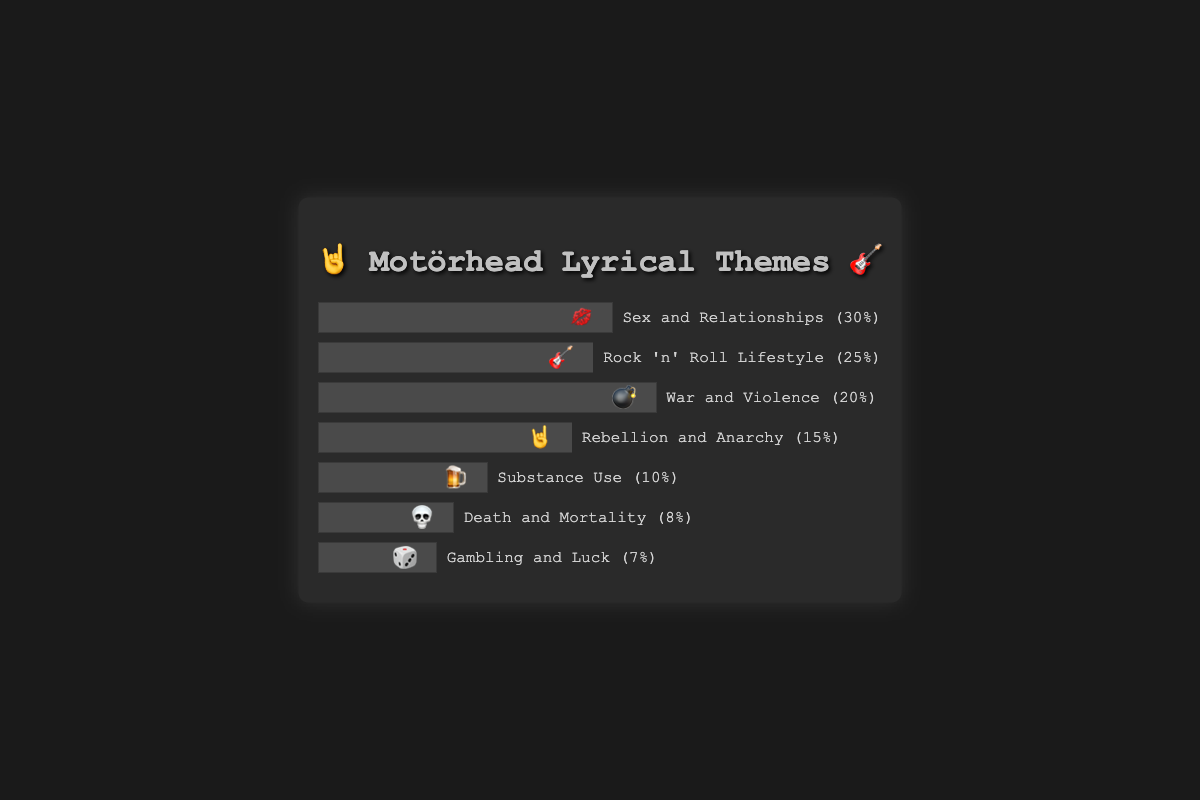What theme appears most frequently in Motörhead's songs? The theme with the highest frequency bar indicates it occurs most often. "Sex and Relationships" has the longest bar.
Answer: Sex and Relationships 💋 How many themes cover 15% or more of the songs? Identify the themes whose frequency percentages are 15 or above by looking at the length of the bars and their labels. The themes are "Sex and Relationships" (30%), "Rock 'n' Roll Lifestyle" (25%), "War and Violence" (20%), and "Rebellion and Anarchy" (15%).
Answer: Four themes Which is the least frequent theme? The theme with the shortest bar indicates it occurs the least. "Gambling and Luck" has the shortest bar.
Answer: Gambling and Luck 🎲 What is the combined frequency percentage of the "War and Violence" and "Substance Use" themes? Add the frequencies of "War and Violence" (20%) and "Substance Use" (10%). The combined frequency is 20% + 10% = 30%.
Answer: 30% Which themes are associated with emojis that signify a danger or a risky situation? Themes represented by emojis that suggest danger or risk are "War and Violence" (💣), "Substance Use" (🍺), and "Death and Mortality" (💀).
Answer: War and Violence 💣, Substance Use 🍺, Death and Mortality 💀 By how much does the frequency of "Sex and Relationships" exceed "Rock 'n' Roll Lifestyle"? Subtract the frequency of "Rock 'n' Roll Lifestyle" (25%) from the frequency of "Sex and Relationships" (30%). The difference is 30% - 25% = 5%.
Answer: 5% What is the total percentage of themes related to death and mortality across Motörhead's songs? The direct frequency of the "Death and Mortality" theme is displayed on the chart as 8%.
Answer: 8% How much less frequent is the "Substance Use" theme compared to the "Rebellion and Anarchy" theme? Subtract the frequency of "Substance Use" (10%) from the frequency of "Rebellion and Anarchy" (15%). The difference is 15% - 10% = 5%.
Answer: 5% Which theme has the third highest frequency and what is its percentage? Order the themes by frequency and find the third highest one. "War and Violence" is the third with a 20% frequency.
Answer: War and Violence 💣, 20% Arrange all the themes in descending order of their frequencies. List the themes from highest to lowest frequency as seen in the chart: "Sex and Relationships" (30%), "Rock 'n' Roll Lifestyle" (25%), "War and Violence" (20%), "Rebellion and Anarchy" (15%), "Substance Use" (10%), "Death and Mortality" (8%), "Gambling and Luck" (7%).
Answer: Sex and Relationships 💋, Rock 'n' Roll Lifestyle 🎸, War and Violence 💣, Rebellion and Anarchy 🤘, Substance Use 🍺, Death and Mortality 💀, Gambling and Luck 🎲 